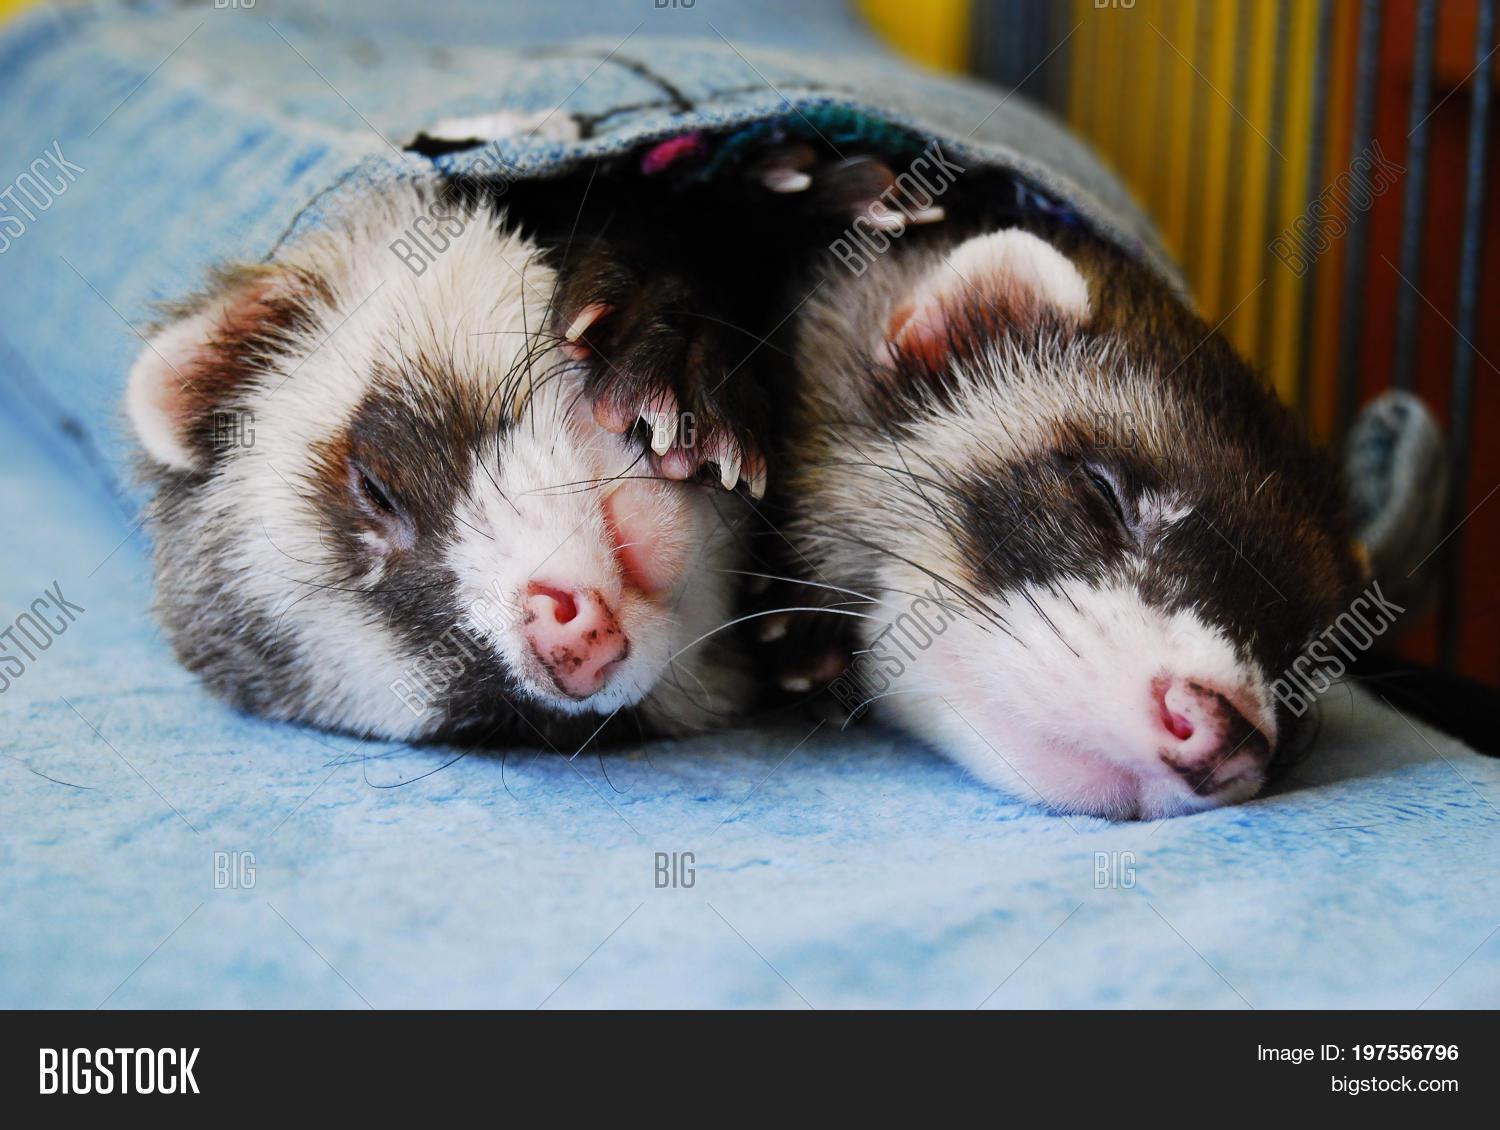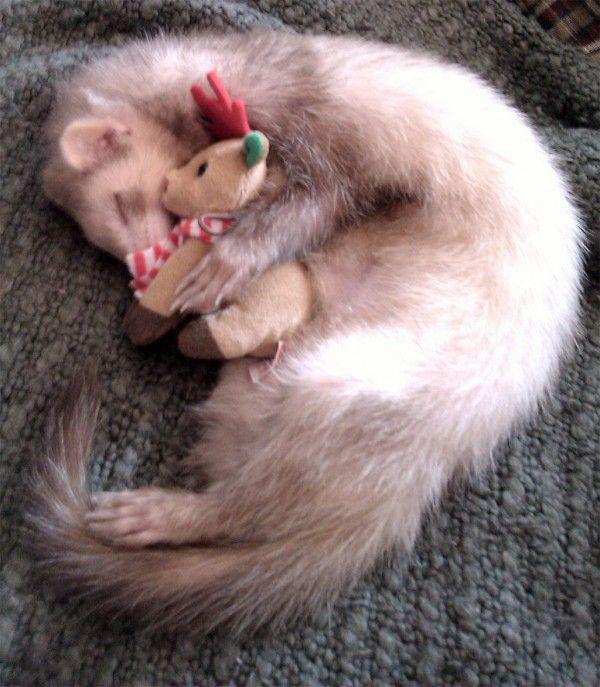The first image is the image on the left, the second image is the image on the right. Considering the images on both sides, is "There is exactly three ferrets in the right image." valid? Answer yes or no. No. The first image is the image on the left, the second image is the image on the right. For the images shown, is this caption "there are 3 ferrets being helpd up together by human hands" true? Answer yes or no. No. 